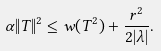<formula> <loc_0><loc_0><loc_500><loc_500>\alpha \| T \| ^ { 2 } \leq w ( T ^ { 2 } ) + \frac { r ^ { 2 } } { 2 | \lambda | } .</formula> 